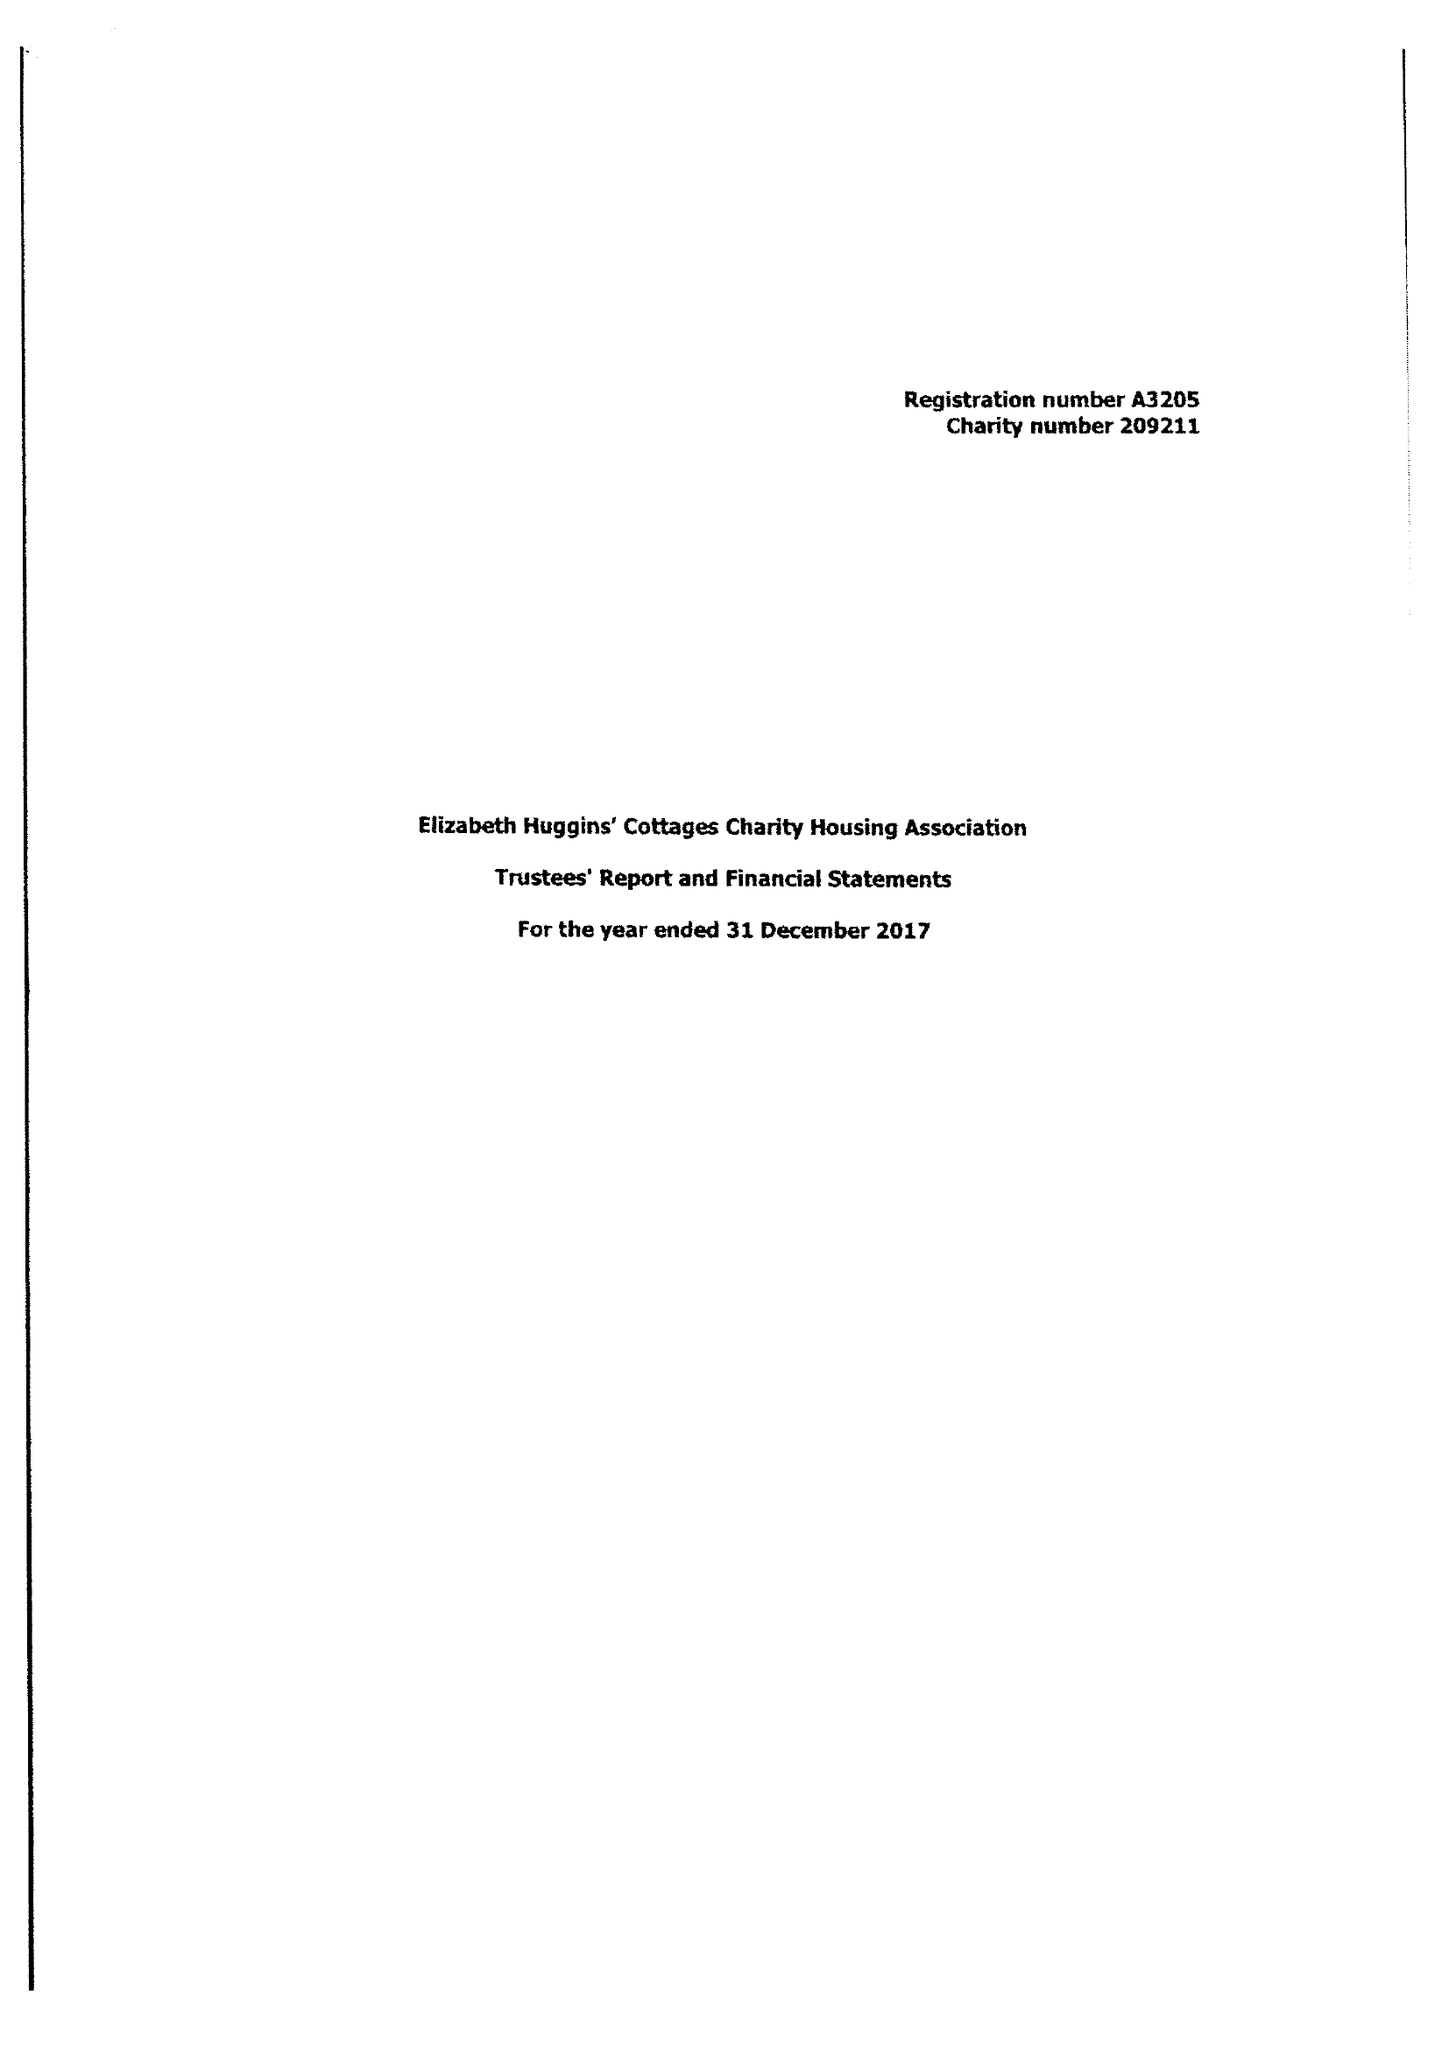What is the value for the address__postcode?
Answer the question using a single word or phrase. DA11 9JQ 